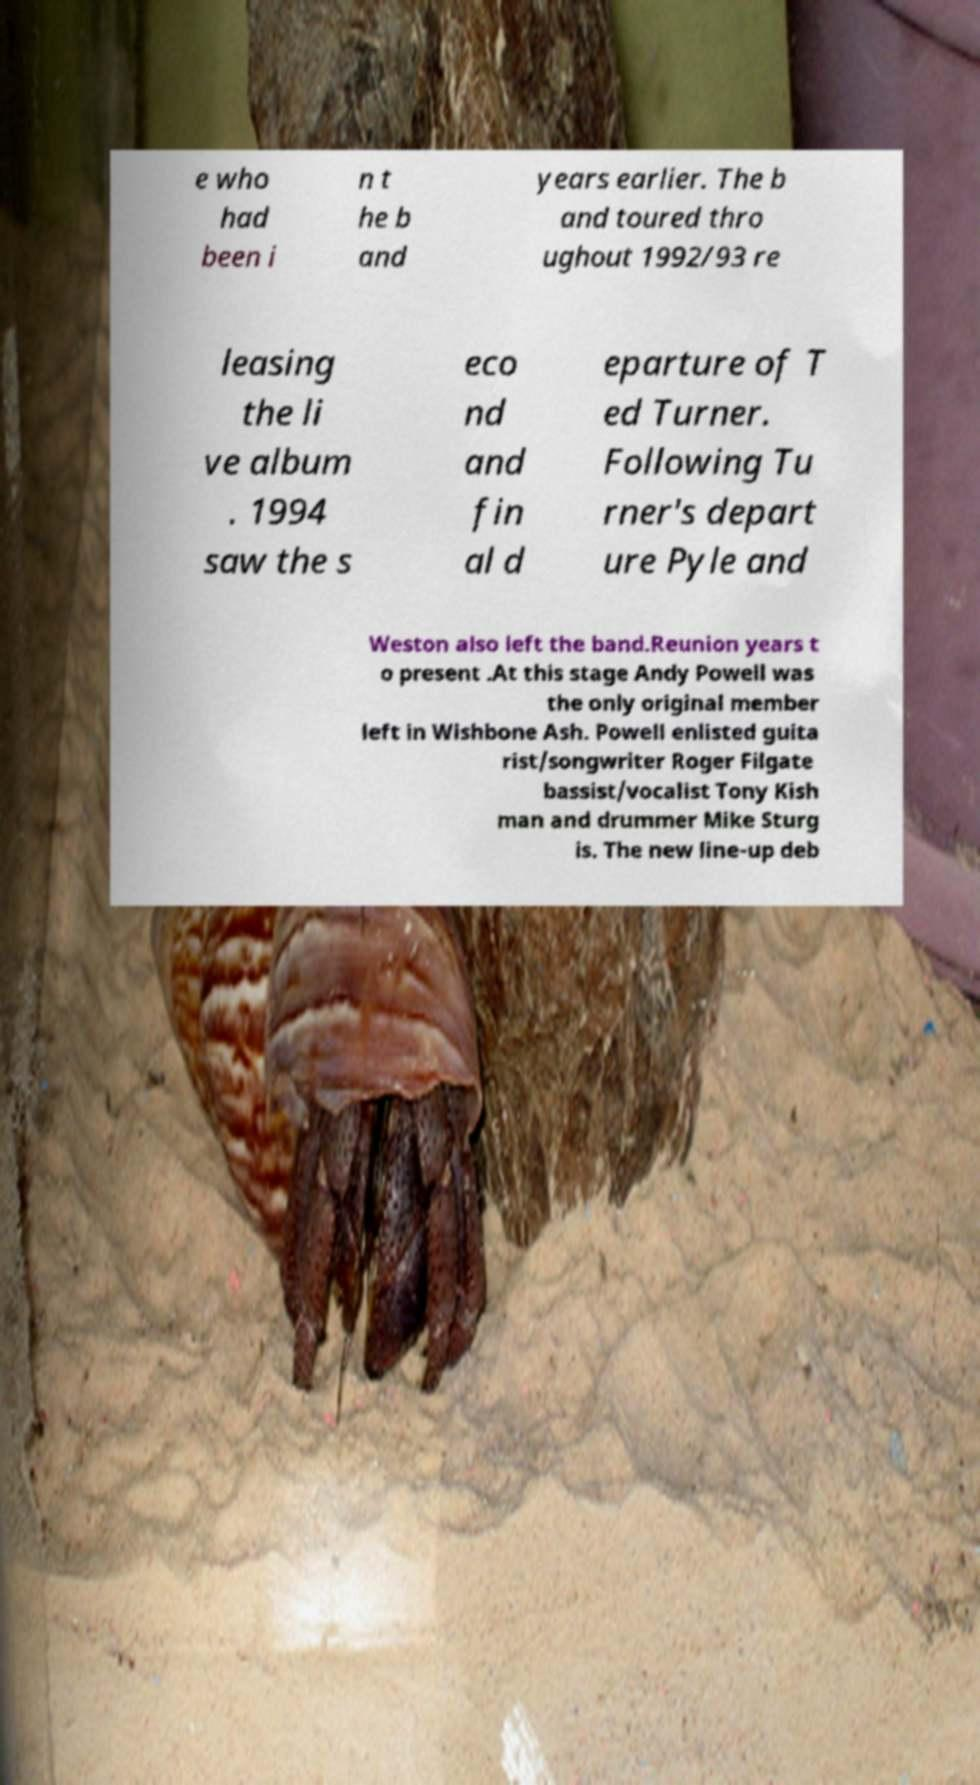There's text embedded in this image that I need extracted. Can you transcribe it verbatim? e who had been i n t he b and years earlier. The b and toured thro ughout 1992/93 re leasing the li ve album . 1994 saw the s eco nd and fin al d eparture of T ed Turner. Following Tu rner's depart ure Pyle and Weston also left the band.Reunion years t o present .At this stage Andy Powell was the only original member left in Wishbone Ash. Powell enlisted guita rist/songwriter Roger Filgate bassist/vocalist Tony Kish man and drummer Mike Sturg is. The new line-up deb 